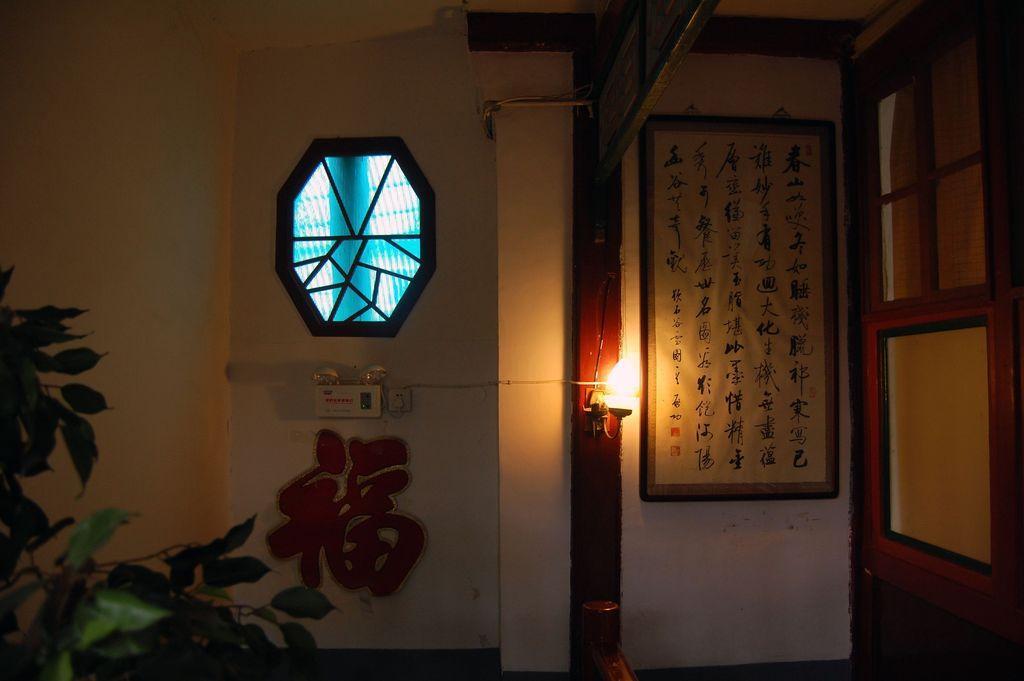Can you describe this image briefly? In the foreground of this image, on the left bottom, there is a plant. In the background, there is a wall, light to the wooden pole, a hexagon shaped structure on the wall, a frame and a wooden wall with windows are on the right side. 